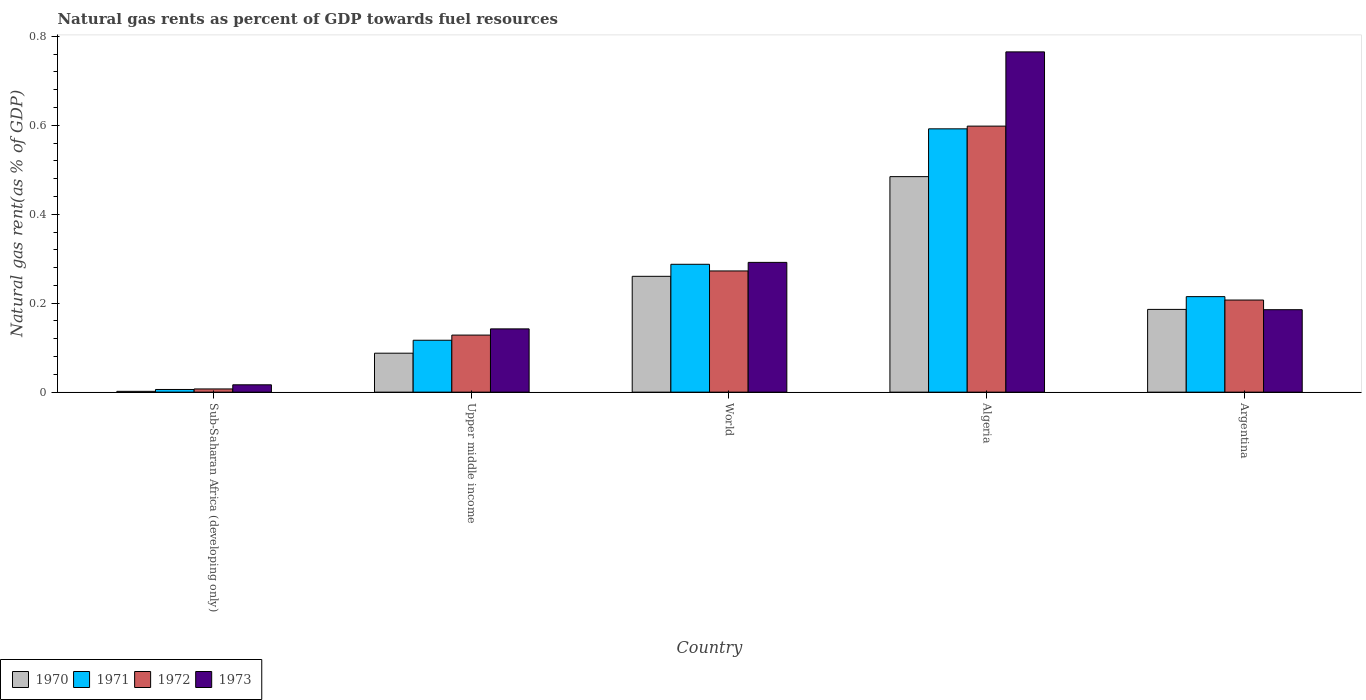How many different coloured bars are there?
Your answer should be compact. 4. How many groups of bars are there?
Your response must be concise. 5. Are the number of bars on each tick of the X-axis equal?
Offer a terse response. Yes. How many bars are there on the 3rd tick from the left?
Provide a short and direct response. 4. How many bars are there on the 2nd tick from the right?
Keep it short and to the point. 4. What is the label of the 1st group of bars from the left?
Give a very brief answer. Sub-Saharan Africa (developing only). What is the natural gas rent in 1970 in Upper middle income?
Make the answer very short. 0.09. Across all countries, what is the maximum natural gas rent in 1970?
Offer a very short reply. 0.48. Across all countries, what is the minimum natural gas rent in 1972?
Ensure brevity in your answer.  0.01. In which country was the natural gas rent in 1970 maximum?
Your answer should be compact. Algeria. In which country was the natural gas rent in 1970 minimum?
Your answer should be compact. Sub-Saharan Africa (developing only). What is the total natural gas rent in 1973 in the graph?
Ensure brevity in your answer.  1.4. What is the difference between the natural gas rent in 1971 in Sub-Saharan Africa (developing only) and that in Upper middle income?
Your answer should be very brief. -0.11. What is the difference between the natural gas rent in 1971 in World and the natural gas rent in 1970 in Argentina?
Your answer should be very brief. 0.1. What is the average natural gas rent in 1973 per country?
Ensure brevity in your answer.  0.28. What is the difference between the natural gas rent of/in 1970 and natural gas rent of/in 1973 in Sub-Saharan Africa (developing only)?
Ensure brevity in your answer.  -0.01. In how many countries, is the natural gas rent in 1970 greater than 0.24000000000000002 %?
Keep it short and to the point. 2. What is the ratio of the natural gas rent in 1972 in Algeria to that in Upper middle income?
Provide a short and direct response. 4.66. Is the natural gas rent in 1970 in Algeria less than that in Sub-Saharan Africa (developing only)?
Ensure brevity in your answer.  No. What is the difference between the highest and the second highest natural gas rent in 1973?
Offer a terse response. 0.58. What is the difference between the highest and the lowest natural gas rent in 1970?
Offer a very short reply. 0.48. How many bars are there?
Offer a very short reply. 20. Are all the bars in the graph horizontal?
Ensure brevity in your answer.  No. Are the values on the major ticks of Y-axis written in scientific E-notation?
Your answer should be compact. No. Does the graph contain any zero values?
Ensure brevity in your answer.  No. Where does the legend appear in the graph?
Provide a short and direct response. Bottom left. How many legend labels are there?
Offer a very short reply. 4. What is the title of the graph?
Offer a terse response. Natural gas rents as percent of GDP towards fuel resources. What is the label or title of the X-axis?
Give a very brief answer. Country. What is the label or title of the Y-axis?
Ensure brevity in your answer.  Natural gas rent(as % of GDP). What is the Natural gas rent(as % of GDP) of 1970 in Sub-Saharan Africa (developing only)?
Offer a very short reply. 0. What is the Natural gas rent(as % of GDP) of 1971 in Sub-Saharan Africa (developing only)?
Make the answer very short. 0.01. What is the Natural gas rent(as % of GDP) in 1972 in Sub-Saharan Africa (developing only)?
Your response must be concise. 0.01. What is the Natural gas rent(as % of GDP) of 1973 in Sub-Saharan Africa (developing only)?
Ensure brevity in your answer.  0.02. What is the Natural gas rent(as % of GDP) of 1970 in Upper middle income?
Give a very brief answer. 0.09. What is the Natural gas rent(as % of GDP) of 1971 in Upper middle income?
Provide a succinct answer. 0.12. What is the Natural gas rent(as % of GDP) in 1972 in Upper middle income?
Provide a succinct answer. 0.13. What is the Natural gas rent(as % of GDP) in 1973 in Upper middle income?
Your answer should be compact. 0.14. What is the Natural gas rent(as % of GDP) of 1970 in World?
Your response must be concise. 0.26. What is the Natural gas rent(as % of GDP) in 1971 in World?
Your answer should be compact. 0.29. What is the Natural gas rent(as % of GDP) in 1972 in World?
Provide a short and direct response. 0.27. What is the Natural gas rent(as % of GDP) in 1973 in World?
Offer a terse response. 0.29. What is the Natural gas rent(as % of GDP) of 1970 in Algeria?
Offer a very short reply. 0.48. What is the Natural gas rent(as % of GDP) of 1971 in Algeria?
Your answer should be compact. 0.59. What is the Natural gas rent(as % of GDP) of 1972 in Algeria?
Offer a terse response. 0.6. What is the Natural gas rent(as % of GDP) of 1973 in Algeria?
Give a very brief answer. 0.76. What is the Natural gas rent(as % of GDP) in 1970 in Argentina?
Offer a terse response. 0.19. What is the Natural gas rent(as % of GDP) of 1971 in Argentina?
Provide a succinct answer. 0.21. What is the Natural gas rent(as % of GDP) of 1972 in Argentina?
Provide a succinct answer. 0.21. What is the Natural gas rent(as % of GDP) of 1973 in Argentina?
Make the answer very short. 0.19. Across all countries, what is the maximum Natural gas rent(as % of GDP) of 1970?
Provide a short and direct response. 0.48. Across all countries, what is the maximum Natural gas rent(as % of GDP) in 1971?
Your answer should be compact. 0.59. Across all countries, what is the maximum Natural gas rent(as % of GDP) in 1972?
Keep it short and to the point. 0.6. Across all countries, what is the maximum Natural gas rent(as % of GDP) of 1973?
Provide a succinct answer. 0.76. Across all countries, what is the minimum Natural gas rent(as % of GDP) of 1970?
Offer a very short reply. 0. Across all countries, what is the minimum Natural gas rent(as % of GDP) of 1971?
Ensure brevity in your answer.  0.01. Across all countries, what is the minimum Natural gas rent(as % of GDP) of 1972?
Ensure brevity in your answer.  0.01. Across all countries, what is the minimum Natural gas rent(as % of GDP) of 1973?
Your answer should be compact. 0.02. What is the total Natural gas rent(as % of GDP) of 1970 in the graph?
Offer a terse response. 1.02. What is the total Natural gas rent(as % of GDP) of 1971 in the graph?
Your answer should be compact. 1.22. What is the total Natural gas rent(as % of GDP) in 1972 in the graph?
Provide a short and direct response. 1.21. What is the total Natural gas rent(as % of GDP) in 1973 in the graph?
Your response must be concise. 1.4. What is the difference between the Natural gas rent(as % of GDP) in 1970 in Sub-Saharan Africa (developing only) and that in Upper middle income?
Offer a very short reply. -0.09. What is the difference between the Natural gas rent(as % of GDP) in 1971 in Sub-Saharan Africa (developing only) and that in Upper middle income?
Keep it short and to the point. -0.11. What is the difference between the Natural gas rent(as % of GDP) in 1972 in Sub-Saharan Africa (developing only) and that in Upper middle income?
Offer a very short reply. -0.12. What is the difference between the Natural gas rent(as % of GDP) in 1973 in Sub-Saharan Africa (developing only) and that in Upper middle income?
Keep it short and to the point. -0.13. What is the difference between the Natural gas rent(as % of GDP) in 1970 in Sub-Saharan Africa (developing only) and that in World?
Make the answer very short. -0.26. What is the difference between the Natural gas rent(as % of GDP) of 1971 in Sub-Saharan Africa (developing only) and that in World?
Give a very brief answer. -0.28. What is the difference between the Natural gas rent(as % of GDP) in 1972 in Sub-Saharan Africa (developing only) and that in World?
Your answer should be compact. -0.27. What is the difference between the Natural gas rent(as % of GDP) in 1973 in Sub-Saharan Africa (developing only) and that in World?
Your answer should be compact. -0.28. What is the difference between the Natural gas rent(as % of GDP) in 1970 in Sub-Saharan Africa (developing only) and that in Algeria?
Your answer should be very brief. -0.48. What is the difference between the Natural gas rent(as % of GDP) of 1971 in Sub-Saharan Africa (developing only) and that in Algeria?
Give a very brief answer. -0.59. What is the difference between the Natural gas rent(as % of GDP) of 1972 in Sub-Saharan Africa (developing only) and that in Algeria?
Provide a short and direct response. -0.59. What is the difference between the Natural gas rent(as % of GDP) of 1973 in Sub-Saharan Africa (developing only) and that in Algeria?
Ensure brevity in your answer.  -0.75. What is the difference between the Natural gas rent(as % of GDP) of 1970 in Sub-Saharan Africa (developing only) and that in Argentina?
Offer a very short reply. -0.18. What is the difference between the Natural gas rent(as % of GDP) in 1971 in Sub-Saharan Africa (developing only) and that in Argentina?
Make the answer very short. -0.21. What is the difference between the Natural gas rent(as % of GDP) of 1972 in Sub-Saharan Africa (developing only) and that in Argentina?
Your answer should be very brief. -0.2. What is the difference between the Natural gas rent(as % of GDP) in 1973 in Sub-Saharan Africa (developing only) and that in Argentina?
Ensure brevity in your answer.  -0.17. What is the difference between the Natural gas rent(as % of GDP) in 1970 in Upper middle income and that in World?
Your answer should be compact. -0.17. What is the difference between the Natural gas rent(as % of GDP) in 1971 in Upper middle income and that in World?
Provide a succinct answer. -0.17. What is the difference between the Natural gas rent(as % of GDP) in 1972 in Upper middle income and that in World?
Provide a short and direct response. -0.14. What is the difference between the Natural gas rent(as % of GDP) of 1973 in Upper middle income and that in World?
Give a very brief answer. -0.15. What is the difference between the Natural gas rent(as % of GDP) of 1970 in Upper middle income and that in Algeria?
Your answer should be very brief. -0.4. What is the difference between the Natural gas rent(as % of GDP) of 1971 in Upper middle income and that in Algeria?
Make the answer very short. -0.48. What is the difference between the Natural gas rent(as % of GDP) in 1972 in Upper middle income and that in Algeria?
Give a very brief answer. -0.47. What is the difference between the Natural gas rent(as % of GDP) in 1973 in Upper middle income and that in Algeria?
Your answer should be compact. -0.62. What is the difference between the Natural gas rent(as % of GDP) in 1970 in Upper middle income and that in Argentina?
Your response must be concise. -0.1. What is the difference between the Natural gas rent(as % of GDP) in 1971 in Upper middle income and that in Argentina?
Keep it short and to the point. -0.1. What is the difference between the Natural gas rent(as % of GDP) of 1972 in Upper middle income and that in Argentina?
Make the answer very short. -0.08. What is the difference between the Natural gas rent(as % of GDP) in 1973 in Upper middle income and that in Argentina?
Your answer should be compact. -0.04. What is the difference between the Natural gas rent(as % of GDP) of 1970 in World and that in Algeria?
Make the answer very short. -0.22. What is the difference between the Natural gas rent(as % of GDP) of 1971 in World and that in Algeria?
Your answer should be very brief. -0.3. What is the difference between the Natural gas rent(as % of GDP) in 1972 in World and that in Algeria?
Ensure brevity in your answer.  -0.33. What is the difference between the Natural gas rent(as % of GDP) in 1973 in World and that in Algeria?
Your answer should be very brief. -0.47. What is the difference between the Natural gas rent(as % of GDP) of 1970 in World and that in Argentina?
Keep it short and to the point. 0.07. What is the difference between the Natural gas rent(as % of GDP) in 1971 in World and that in Argentina?
Make the answer very short. 0.07. What is the difference between the Natural gas rent(as % of GDP) in 1972 in World and that in Argentina?
Ensure brevity in your answer.  0.07. What is the difference between the Natural gas rent(as % of GDP) of 1973 in World and that in Argentina?
Give a very brief answer. 0.11. What is the difference between the Natural gas rent(as % of GDP) of 1970 in Algeria and that in Argentina?
Make the answer very short. 0.3. What is the difference between the Natural gas rent(as % of GDP) in 1971 in Algeria and that in Argentina?
Ensure brevity in your answer.  0.38. What is the difference between the Natural gas rent(as % of GDP) of 1972 in Algeria and that in Argentina?
Provide a short and direct response. 0.39. What is the difference between the Natural gas rent(as % of GDP) in 1973 in Algeria and that in Argentina?
Offer a terse response. 0.58. What is the difference between the Natural gas rent(as % of GDP) of 1970 in Sub-Saharan Africa (developing only) and the Natural gas rent(as % of GDP) of 1971 in Upper middle income?
Keep it short and to the point. -0.11. What is the difference between the Natural gas rent(as % of GDP) in 1970 in Sub-Saharan Africa (developing only) and the Natural gas rent(as % of GDP) in 1972 in Upper middle income?
Keep it short and to the point. -0.13. What is the difference between the Natural gas rent(as % of GDP) in 1970 in Sub-Saharan Africa (developing only) and the Natural gas rent(as % of GDP) in 1973 in Upper middle income?
Your response must be concise. -0.14. What is the difference between the Natural gas rent(as % of GDP) in 1971 in Sub-Saharan Africa (developing only) and the Natural gas rent(as % of GDP) in 1972 in Upper middle income?
Offer a terse response. -0.12. What is the difference between the Natural gas rent(as % of GDP) in 1971 in Sub-Saharan Africa (developing only) and the Natural gas rent(as % of GDP) in 1973 in Upper middle income?
Keep it short and to the point. -0.14. What is the difference between the Natural gas rent(as % of GDP) in 1972 in Sub-Saharan Africa (developing only) and the Natural gas rent(as % of GDP) in 1973 in Upper middle income?
Make the answer very short. -0.14. What is the difference between the Natural gas rent(as % of GDP) in 1970 in Sub-Saharan Africa (developing only) and the Natural gas rent(as % of GDP) in 1971 in World?
Ensure brevity in your answer.  -0.29. What is the difference between the Natural gas rent(as % of GDP) in 1970 in Sub-Saharan Africa (developing only) and the Natural gas rent(as % of GDP) in 1972 in World?
Offer a terse response. -0.27. What is the difference between the Natural gas rent(as % of GDP) in 1970 in Sub-Saharan Africa (developing only) and the Natural gas rent(as % of GDP) in 1973 in World?
Keep it short and to the point. -0.29. What is the difference between the Natural gas rent(as % of GDP) in 1971 in Sub-Saharan Africa (developing only) and the Natural gas rent(as % of GDP) in 1972 in World?
Offer a very short reply. -0.27. What is the difference between the Natural gas rent(as % of GDP) in 1971 in Sub-Saharan Africa (developing only) and the Natural gas rent(as % of GDP) in 1973 in World?
Offer a very short reply. -0.29. What is the difference between the Natural gas rent(as % of GDP) of 1972 in Sub-Saharan Africa (developing only) and the Natural gas rent(as % of GDP) of 1973 in World?
Give a very brief answer. -0.28. What is the difference between the Natural gas rent(as % of GDP) of 1970 in Sub-Saharan Africa (developing only) and the Natural gas rent(as % of GDP) of 1971 in Algeria?
Your answer should be compact. -0.59. What is the difference between the Natural gas rent(as % of GDP) in 1970 in Sub-Saharan Africa (developing only) and the Natural gas rent(as % of GDP) in 1972 in Algeria?
Keep it short and to the point. -0.6. What is the difference between the Natural gas rent(as % of GDP) in 1970 in Sub-Saharan Africa (developing only) and the Natural gas rent(as % of GDP) in 1973 in Algeria?
Give a very brief answer. -0.76. What is the difference between the Natural gas rent(as % of GDP) in 1971 in Sub-Saharan Africa (developing only) and the Natural gas rent(as % of GDP) in 1972 in Algeria?
Give a very brief answer. -0.59. What is the difference between the Natural gas rent(as % of GDP) in 1971 in Sub-Saharan Africa (developing only) and the Natural gas rent(as % of GDP) in 1973 in Algeria?
Your answer should be compact. -0.76. What is the difference between the Natural gas rent(as % of GDP) of 1972 in Sub-Saharan Africa (developing only) and the Natural gas rent(as % of GDP) of 1973 in Algeria?
Make the answer very short. -0.76. What is the difference between the Natural gas rent(as % of GDP) in 1970 in Sub-Saharan Africa (developing only) and the Natural gas rent(as % of GDP) in 1971 in Argentina?
Offer a terse response. -0.21. What is the difference between the Natural gas rent(as % of GDP) of 1970 in Sub-Saharan Africa (developing only) and the Natural gas rent(as % of GDP) of 1972 in Argentina?
Offer a very short reply. -0.21. What is the difference between the Natural gas rent(as % of GDP) in 1970 in Sub-Saharan Africa (developing only) and the Natural gas rent(as % of GDP) in 1973 in Argentina?
Keep it short and to the point. -0.18. What is the difference between the Natural gas rent(as % of GDP) in 1971 in Sub-Saharan Africa (developing only) and the Natural gas rent(as % of GDP) in 1972 in Argentina?
Offer a very short reply. -0.2. What is the difference between the Natural gas rent(as % of GDP) of 1971 in Sub-Saharan Africa (developing only) and the Natural gas rent(as % of GDP) of 1973 in Argentina?
Ensure brevity in your answer.  -0.18. What is the difference between the Natural gas rent(as % of GDP) of 1972 in Sub-Saharan Africa (developing only) and the Natural gas rent(as % of GDP) of 1973 in Argentina?
Your answer should be compact. -0.18. What is the difference between the Natural gas rent(as % of GDP) of 1970 in Upper middle income and the Natural gas rent(as % of GDP) of 1971 in World?
Give a very brief answer. -0.2. What is the difference between the Natural gas rent(as % of GDP) of 1970 in Upper middle income and the Natural gas rent(as % of GDP) of 1972 in World?
Ensure brevity in your answer.  -0.18. What is the difference between the Natural gas rent(as % of GDP) of 1970 in Upper middle income and the Natural gas rent(as % of GDP) of 1973 in World?
Your response must be concise. -0.2. What is the difference between the Natural gas rent(as % of GDP) in 1971 in Upper middle income and the Natural gas rent(as % of GDP) in 1972 in World?
Offer a terse response. -0.16. What is the difference between the Natural gas rent(as % of GDP) in 1971 in Upper middle income and the Natural gas rent(as % of GDP) in 1973 in World?
Give a very brief answer. -0.17. What is the difference between the Natural gas rent(as % of GDP) of 1972 in Upper middle income and the Natural gas rent(as % of GDP) of 1973 in World?
Provide a succinct answer. -0.16. What is the difference between the Natural gas rent(as % of GDP) of 1970 in Upper middle income and the Natural gas rent(as % of GDP) of 1971 in Algeria?
Offer a terse response. -0.5. What is the difference between the Natural gas rent(as % of GDP) of 1970 in Upper middle income and the Natural gas rent(as % of GDP) of 1972 in Algeria?
Provide a succinct answer. -0.51. What is the difference between the Natural gas rent(as % of GDP) of 1970 in Upper middle income and the Natural gas rent(as % of GDP) of 1973 in Algeria?
Make the answer very short. -0.68. What is the difference between the Natural gas rent(as % of GDP) of 1971 in Upper middle income and the Natural gas rent(as % of GDP) of 1972 in Algeria?
Make the answer very short. -0.48. What is the difference between the Natural gas rent(as % of GDP) in 1971 in Upper middle income and the Natural gas rent(as % of GDP) in 1973 in Algeria?
Your answer should be very brief. -0.65. What is the difference between the Natural gas rent(as % of GDP) of 1972 in Upper middle income and the Natural gas rent(as % of GDP) of 1973 in Algeria?
Keep it short and to the point. -0.64. What is the difference between the Natural gas rent(as % of GDP) in 1970 in Upper middle income and the Natural gas rent(as % of GDP) in 1971 in Argentina?
Give a very brief answer. -0.13. What is the difference between the Natural gas rent(as % of GDP) in 1970 in Upper middle income and the Natural gas rent(as % of GDP) in 1972 in Argentina?
Your response must be concise. -0.12. What is the difference between the Natural gas rent(as % of GDP) of 1970 in Upper middle income and the Natural gas rent(as % of GDP) of 1973 in Argentina?
Keep it short and to the point. -0.1. What is the difference between the Natural gas rent(as % of GDP) of 1971 in Upper middle income and the Natural gas rent(as % of GDP) of 1972 in Argentina?
Give a very brief answer. -0.09. What is the difference between the Natural gas rent(as % of GDP) of 1971 in Upper middle income and the Natural gas rent(as % of GDP) of 1973 in Argentina?
Offer a terse response. -0.07. What is the difference between the Natural gas rent(as % of GDP) in 1972 in Upper middle income and the Natural gas rent(as % of GDP) in 1973 in Argentina?
Offer a very short reply. -0.06. What is the difference between the Natural gas rent(as % of GDP) in 1970 in World and the Natural gas rent(as % of GDP) in 1971 in Algeria?
Your response must be concise. -0.33. What is the difference between the Natural gas rent(as % of GDP) in 1970 in World and the Natural gas rent(as % of GDP) in 1972 in Algeria?
Give a very brief answer. -0.34. What is the difference between the Natural gas rent(as % of GDP) of 1970 in World and the Natural gas rent(as % of GDP) of 1973 in Algeria?
Ensure brevity in your answer.  -0.5. What is the difference between the Natural gas rent(as % of GDP) of 1971 in World and the Natural gas rent(as % of GDP) of 1972 in Algeria?
Provide a short and direct response. -0.31. What is the difference between the Natural gas rent(as % of GDP) in 1971 in World and the Natural gas rent(as % of GDP) in 1973 in Algeria?
Give a very brief answer. -0.48. What is the difference between the Natural gas rent(as % of GDP) in 1972 in World and the Natural gas rent(as % of GDP) in 1973 in Algeria?
Offer a very short reply. -0.49. What is the difference between the Natural gas rent(as % of GDP) in 1970 in World and the Natural gas rent(as % of GDP) in 1971 in Argentina?
Ensure brevity in your answer.  0.05. What is the difference between the Natural gas rent(as % of GDP) of 1970 in World and the Natural gas rent(as % of GDP) of 1972 in Argentina?
Make the answer very short. 0.05. What is the difference between the Natural gas rent(as % of GDP) in 1970 in World and the Natural gas rent(as % of GDP) in 1973 in Argentina?
Offer a very short reply. 0.07. What is the difference between the Natural gas rent(as % of GDP) in 1971 in World and the Natural gas rent(as % of GDP) in 1972 in Argentina?
Keep it short and to the point. 0.08. What is the difference between the Natural gas rent(as % of GDP) in 1971 in World and the Natural gas rent(as % of GDP) in 1973 in Argentina?
Provide a short and direct response. 0.1. What is the difference between the Natural gas rent(as % of GDP) in 1972 in World and the Natural gas rent(as % of GDP) in 1973 in Argentina?
Keep it short and to the point. 0.09. What is the difference between the Natural gas rent(as % of GDP) of 1970 in Algeria and the Natural gas rent(as % of GDP) of 1971 in Argentina?
Offer a very short reply. 0.27. What is the difference between the Natural gas rent(as % of GDP) of 1970 in Algeria and the Natural gas rent(as % of GDP) of 1972 in Argentina?
Provide a short and direct response. 0.28. What is the difference between the Natural gas rent(as % of GDP) in 1970 in Algeria and the Natural gas rent(as % of GDP) in 1973 in Argentina?
Provide a succinct answer. 0.3. What is the difference between the Natural gas rent(as % of GDP) of 1971 in Algeria and the Natural gas rent(as % of GDP) of 1972 in Argentina?
Offer a terse response. 0.38. What is the difference between the Natural gas rent(as % of GDP) of 1971 in Algeria and the Natural gas rent(as % of GDP) of 1973 in Argentina?
Provide a succinct answer. 0.41. What is the difference between the Natural gas rent(as % of GDP) in 1972 in Algeria and the Natural gas rent(as % of GDP) in 1973 in Argentina?
Give a very brief answer. 0.41. What is the average Natural gas rent(as % of GDP) in 1970 per country?
Provide a short and direct response. 0.2. What is the average Natural gas rent(as % of GDP) of 1971 per country?
Provide a succinct answer. 0.24. What is the average Natural gas rent(as % of GDP) in 1972 per country?
Offer a very short reply. 0.24. What is the average Natural gas rent(as % of GDP) of 1973 per country?
Provide a short and direct response. 0.28. What is the difference between the Natural gas rent(as % of GDP) of 1970 and Natural gas rent(as % of GDP) of 1971 in Sub-Saharan Africa (developing only)?
Your answer should be very brief. -0. What is the difference between the Natural gas rent(as % of GDP) of 1970 and Natural gas rent(as % of GDP) of 1972 in Sub-Saharan Africa (developing only)?
Offer a very short reply. -0.01. What is the difference between the Natural gas rent(as % of GDP) in 1970 and Natural gas rent(as % of GDP) in 1973 in Sub-Saharan Africa (developing only)?
Your answer should be very brief. -0.01. What is the difference between the Natural gas rent(as % of GDP) of 1971 and Natural gas rent(as % of GDP) of 1972 in Sub-Saharan Africa (developing only)?
Make the answer very short. -0. What is the difference between the Natural gas rent(as % of GDP) of 1971 and Natural gas rent(as % of GDP) of 1973 in Sub-Saharan Africa (developing only)?
Give a very brief answer. -0.01. What is the difference between the Natural gas rent(as % of GDP) of 1972 and Natural gas rent(as % of GDP) of 1973 in Sub-Saharan Africa (developing only)?
Offer a very short reply. -0.01. What is the difference between the Natural gas rent(as % of GDP) of 1970 and Natural gas rent(as % of GDP) of 1971 in Upper middle income?
Provide a succinct answer. -0.03. What is the difference between the Natural gas rent(as % of GDP) in 1970 and Natural gas rent(as % of GDP) in 1972 in Upper middle income?
Ensure brevity in your answer.  -0.04. What is the difference between the Natural gas rent(as % of GDP) of 1970 and Natural gas rent(as % of GDP) of 1973 in Upper middle income?
Your answer should be compact. -0.05. What is the difference between the Natural gas rent(as % of GDP) in 1971 and Natural gas rent(as % of GDP) in 1972 in Upper middle income?
Your answer should be compact. -0.01. What is the difference between the Natural gas rent(as % of GDP) of 1971 and Natural gas rent(as % of GDP) of 1973 in Upper middle income?
Offer a very short reply. -0.03. What is the difference between the Natural gas rent(as % of GDP) in 1972 and Natural gas rent(as % of GDP) in 1973 in Upper middle income?
Offer a very short reply. -0.01. What is the difference between the Natural gas rent(as % of GDP) in 1970 and Natural gas rent(as % of GDP) in 1971 in World?
Provide a short and direct response. -0.03. What is the difference between the Natural gas rent(as % of GDP) in 1970 and Natural gas rent(as % of GDP) in 1972 in World?
Your answer should be compact. -0.01. What is the difference between the Natural gas rent(as % of GDP) of 1970 and Natural gas rent(as % of GDP) of 1973 in World?
Provide a short and direct response. -0.03. What is the difference between the Natural gas rent(as % of GDP) in 1971 and Natural gas rent(as % of GDP) in 1972 in World?
Your response must be concise. 0.01. What is the difference between the Natural gas rent(as % of GDP) in 1971 and Natural gas rent(as % of GDP) in 1973 in World?
Make the answer very short. -0. What is the difference between the Natural gas rent(as % of GDP) in 1972 and Natural gas rent(as % of GDP) in 1973 in World?
Offer a terse response. -0.02. What is the difference between the Natural gas rent(as % of GDP) of 1970 and Natural gas rent(as % of GDP) of 1971 in Algeria?
Your answer should be very brief. -0.11. What is the difference between the Natural gas rent(as % of GDP) in 1970 and Natural gas rent(as % of GDP) in 1972 in Algeria?
Your answer should be very brief. -0.11. What is the difference between the Natural gas rent(as % of GDP) in 1970 and Natural gas rent(as % of GDP) in 1973 in Algeria?
Keep it short and to the point. -0.28. What is the difference between the Natural gas rent(as % of GDP) of 1971 and Natural gas rent(as % of GDP) of 1972 in Algeria?
Ensure brevity in your answer.  -0.01. What is the difference between the Natural gas rent(as % of GDP) of 1971 and Natural gas rent(as % of GDP) of 1973 in Algeria?
Provide a short and direct response. -0.17. What is the difference between the Natural gas rent(as % of GDP) in 1972 and Natural gas rent(as % of GDP) in 1973 in Algeria?
Keep it short and to the point. -0.17. What is the difference between the Natural gas rent(as % of GDP) in 1970 and Natural gas rent(as % of GDP) in 1971 in Argentina?
Give a very brief answer. -0.03. What is the difference between the Natural gas rent(as % of GDP) of 1970 and Natural gas rent(as % of GDP) of 1972 in Argentina?
Offer a terse response. -0.02. What is the difference between the Natural gas rent(as % of GDP) in 1970 and Natural gas rent(as % of GDP) in 1973 in Argentina?
Your response must be concise. 0. What is the difference between the Natural gas rent(as % of GDP) in 1971 and Natural gas rent(as % of GDP) in 1972 in Argentina?
Offer a very short reply. 0.01. What is the difference between the Natural gas rent(as % of GDP) of 1971 and Natural gas rent(as % of GDP) of 1973 in Argentina?
Provide a succinct answer. 0.03. What is the difference between the Natural gas rent(as % of GDP) of 1972 and Natural gas rent(as % of GDP) of 1973 in Argentina?
Ensure brevity in your answer.  0.02. What is the ratio of the Natural gas rent(as % of GDP) of 1970 in Sub-Saharan Africa (developing only) to that in Upper middle income?
Provide a succinct answer. 0.02. What is the ratio of the Natural gas rent(as % of GDP) in 1971 in Sub-Saharan Africa (developing only) to that in Upper middle income?
Provide a succinct answer. 0.05. What is the ratio of the Natural gas rent(as % of GDP) of 1972 in Sub-Saharan Africa (developing only) to that in Upper middle income?
Provide a short and direct response. 0.06. What is the ratio of the Natural gas rent(as % of GDP) in 1973 in Sub-Saharan Africa (developing only) to that in Upper middle income?
Make the answer very short. 0.12. What is the ratio of the Natural gas rent(as % of GDP) of 1970 in Sub-Saharan Africa (developing only) to that in World?
Make the answer very short. 0.01. What is the ratio of the Natural gas rent(as % of GDP) of 1971 in Sub-Saharan Africa (developing only) to that in World?
Provide a succinct answer. 0.02. What is the ratio of the Natural gas rent(as % of GDP) in 1972 in Sub-Saharan Africa (developing only) to that in World?
Offer a very short reply. 0.03. What is the ratio of the Natural gas rent(as % of GDP) of 1973 in Sub-Saharan Africa (developing only) to that in World?
Provide a short and direct response. 0.06. What is the ratio of the Natural gas rent(as % of GDP) of 1970 in Sub-Saharan Africa (developing only) to that in Algeria?
Provide a short and direct response. 0. What is the ratio of the Natural gas rent(as % of GDP) in 1971 in Sub-Saharan Africa (developing only) to that in Algeria?
Ensure brevity in your answer.  0.01. What is the ratio of the Natural gas rent(as % of GDP) in 1972 in Sub-Saharan Africa (developing only) to that in Algeria?
Your answer should be very brief. 0.01. What is the ratio of the Natural gas rent(as % of GDP) of 1973 in Sub-Saharan Africa (developing only) to that in Algeria?
Give a very brief answer. 0.02. What is the ratio of the Natural gas rent(as % of GDP) of 1970 in Sub-Saharan Africa (developing only) to that in Argentina?
Ensure brevity in your answer.  0.01. What is the ratio of the Natural gas rent(as % of GDP) in 1971 in Sub-Saharan Africa (developing only) to that in Argentina?
Your answer should be compact. 0.03. What is the ratio of the Natural gas rent(as % of GDP) in 1972 in Sub-Saharan Africa (developing only) to that in Argentina?
Your answer should be very brief. 0.03. What is the ratio of the Natural gas rent(as % of GDP) in 1973 in Sub-Saharan Africa (developing only) to that in Argentina?
Provide a succinct answer. 0.09. What is the ratio of the Natural gas rent(as % of GDP) in 1970 in Upper middle income to that in World?
Make the answer very short. 0.34. What is the ratio of the Natural gas rent(as % of GDP) in 1971 in Upper middle income to that in World?
Your answer should be compact. 0.41. What is the ratio of the Natural gas rent(as % of GDP) of 1972 in Upper middle income to that in World?
Offer a terse response. 0.47. What is the ratio of the Natural gas rent(as % of GDP) in 1973 in Upper middle income to that in World?
Ensure brevity in your answer.  0.49. What is the ratio of the Natural gas rent(as % of GDP) of 1970 in Upper middle income to that in Algeria?
Your response must be concise. 0.18. What is the ratio of the Natural gas rent(as % of GDP) in 1971 in Upper middle income to that in Algeria?
Provide a succinct answer. 0.2. What is the ratio of the Natural gas rent(as % of GDP) in 1972 in Upper middle income to that in Algeria?
Offer a terse response. 0.21. What is the ratio of the Natural gas rent(as % of GDP) of 1973 in Upper middle income to that in Algeria?
Ensure brevity in your answer.  0.19. What is the ratio of the Natural gas rent(as % of GDP) of 1970 in Upper middle income to that in Argentina?
Offer a terse response. 0.47. What is the ratio of the Natural gas rent(as % of GDP) in 1971 in Upper middle income to that in Argentina?
Your answer should be compact. 0.54. What is the ratio of the Natural gas rent(as % of GDP) in 1972 in Upper middle income to that in Argentina?
Provide a short and direct response. 0.62. What is the ratio of the Natural gas rent(as % of GDP) in 1973 in Upper middle income to that in Argentina?
Provide a succinct answer. 0.77. What is the ratio of the Natural gas rent(as % of GDP) of 1970 in World to that in Algeria?
Your answer should be very brief. 0.54. What is the ratio of the Natural gas rent(as % of GDP) of 1971 in World to that in Algeria?
Offer a terse response. 0.49. What is the ratio of the Natural gas rent(as % of GDP) in 1972 in World to that in Algeria?
Offer a very short reply. 0.46. What is the ratio of the Natural gas rent(as % of GDP) in 1973 in World to that in Algeria?
Provide a succinct answer. 0.38. What is the ratio of the Natural gas rent(as % of GDP) in 1970 in World to that in Argentina?
Provide a short and direct response. 1.4. What is the ratio of the Natural gas rent(as % of GDP) of 1971 in World to that in Argentina?
Your answer should be very brief. 1.34. What is the ratio of the Natural gas rent(as % of GDP) in 1972 in World to that in Argentina?
Your answer should be very brief. 1.32. What is the ratio of the Natural gas rent(as % of GDP) in 1973 in World to that in Argentina?
Your response must be concise. 1.57. What is the ratio of the Natural gas rent(as % of GDP) in 1970 in Algeria to that in Argentina?
Your answer should be very brief. 2.6. What is the ratio of the Natural gas rent(as % of GDP) of 1971 in Algeria to that in Argentina?
Offer a terse response. 2.76. What is the ratio of the Natural gas rent(as % of GDP) of 1972 in Algeria to that in Argentina?
Give a very brief answer. 2.89. What is the ratio of the Natural gas rent(as % of GDP) of 1973 in Algeria to that in Argentina?
Provide a succinct answer. 4.13. What is the difference between the highest and the second highest Natural gas rent(as % of GDP) in 1970?
Your response must be concise. 0.22. What is the difference between the highest and the second highest Natural gas rent(as % of GDP) of 1971?
Provide a succinct answer. 0.3. What is the difference between the highest and the second highest Natural gas rent(as % of GDP) in 1972?
Keep it short and to the point. 0.33. What is the difference between the highest and the second highest Natural gas rent(as % of GDP) in 1973?
Your answer should be compact. 0.47. What is the difference between the highest and the lowest Natural gas rent(as % of GDP) in 1970?
Ensure brevity in your answer.  0.48. What is the difference between the highest and the lowest Natural gas rent(as % of GDP) of 1971?
Your answer should be very brief. 0.59. What is the difference between the highest and the lowest Natural gas rent(as % of GDP) of 1972?
Offer a very short reply. 0.59. What is the difference between the highest and the lowest Natural gas rent(as % of GDP) of 1973?
Your response must be concise. 0.75. 